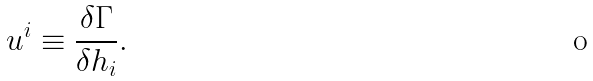<formula> <loc_0><loc_0><loc_500><loc_500>u ^ { i } \equiv \frac { \delta \Gamma } { \delta h _ { i } } .</formula> 